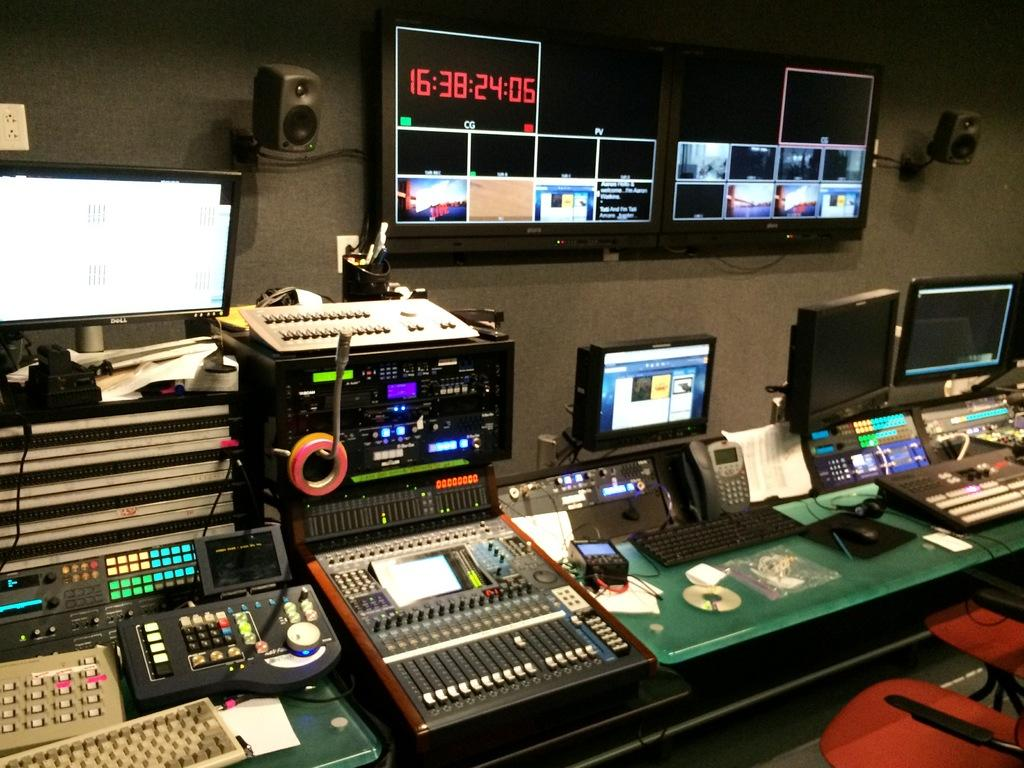<image>
Present a compact description of the photo's key features. A room with screens and different kinds of boards with switches and keys, displays digital numbers of 16:38:24:05. 